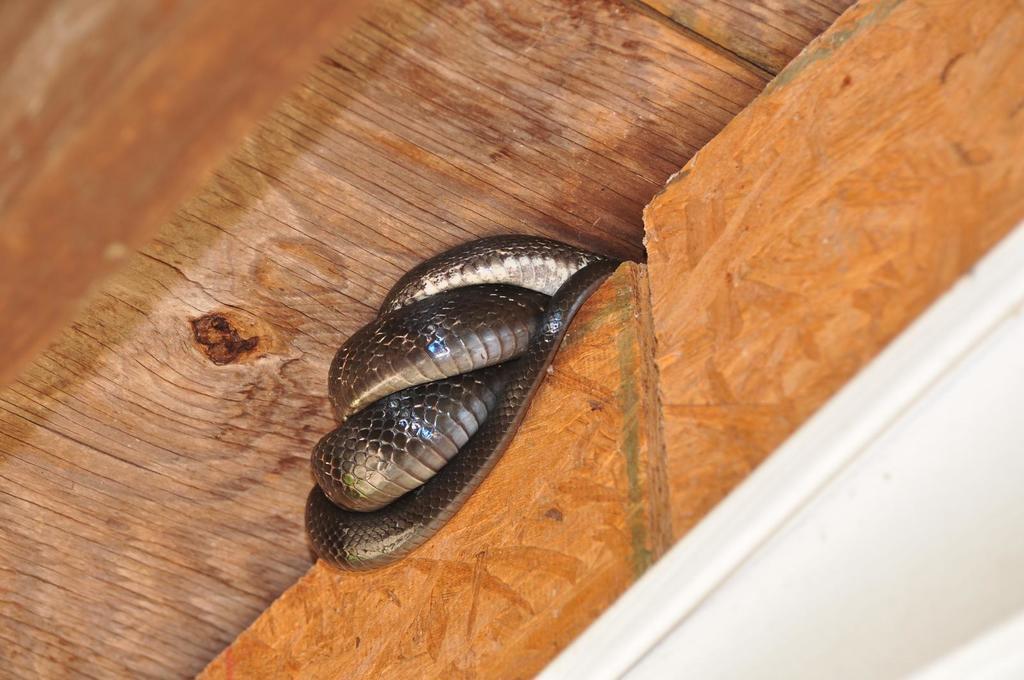Please provide a concise description of this image. In this image there is a snake on the wall. At the bottom of the image there is a wooden floor. 